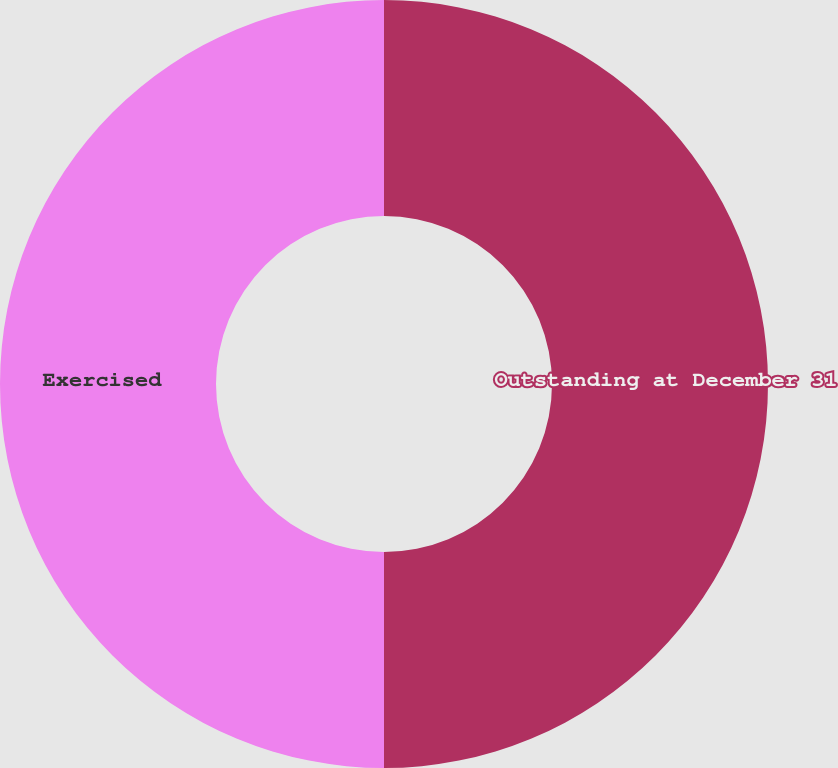<chart> <loc_0><loc_0><loc_500><loc_500><pie_chart><fcel>Outstanding at December 31<fcel>Exercised<nl><fcel>50.0%<fcel>50.0%<nl></chart> 